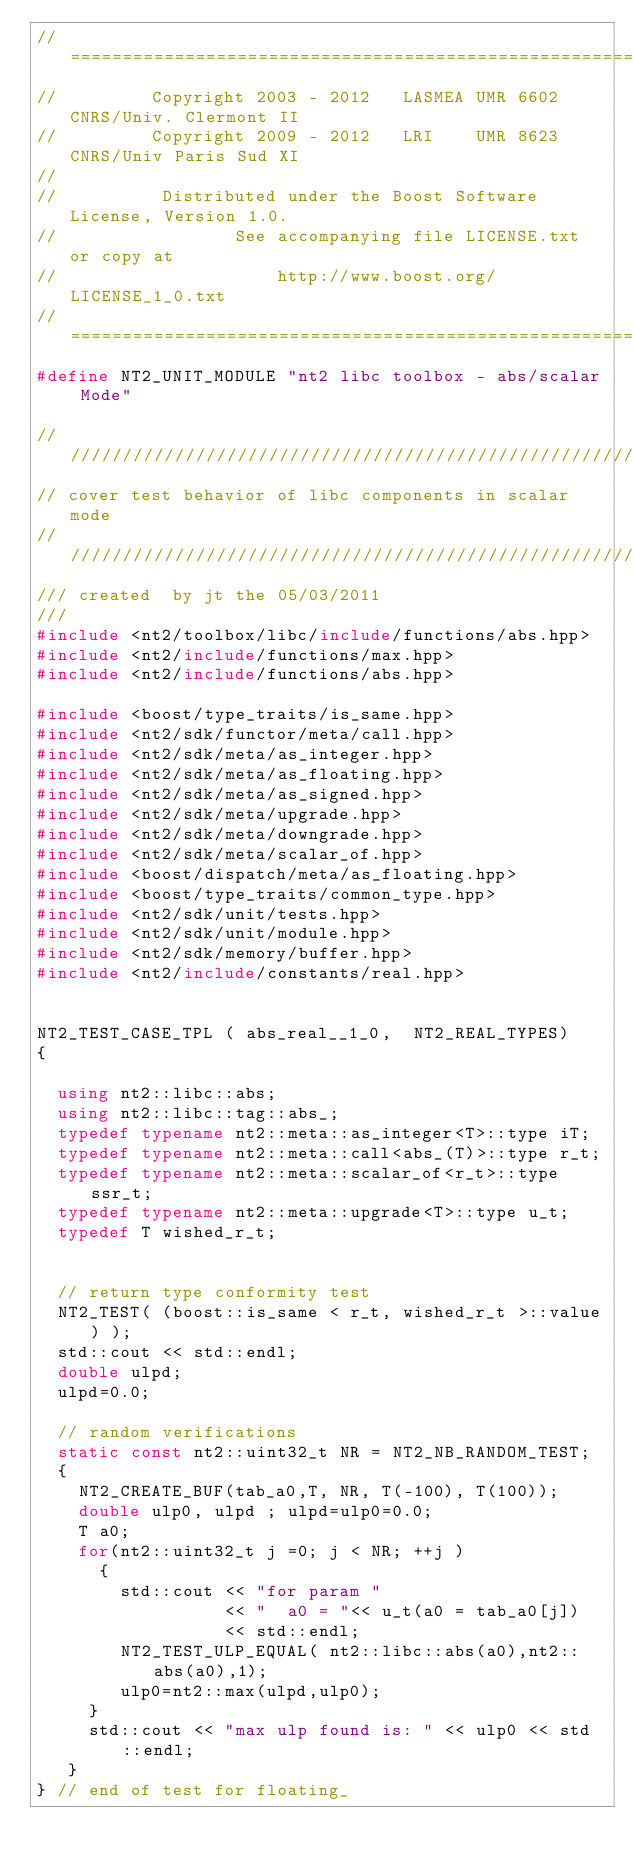<code> <loc_0><loc_0><loc_500><loc_500><_C++_>//==============================================================================
//         Copyright 2003 - 2012   LASMEA UMR 6602 CNRS/Univ. Clermont II
//         Copyright 2009 - 2012   LRI    UMR 8623 CNRS/Univ Paris Sud XI
//
//          Distributed under the Boost Software License, Version 1.0.
//                 See accompanying file LICENSE.txt or copy at
//                     http://www.boost.org/LICENSE_1_0.txt
//==============================================================================
#define NT2_UNIT_MODULE "nt2 libc toolbox - abs/scalar Mode"

//////////////////////////////////////////////////////////////////////////////
// cover test behavior of libc components in scalar mode
//////////////////////////////////////////////////////////////////////////////
/// created  by jt the 05/03/2011
///
#include <nt2/toolbox/libc/include/functions/abs.hpp>
#include <nt2/include/functions/max.hpp>
#include <nt2/include/functions/abs.hpp>

#include <boost/type_traits/is_same.hpp>
#include <nt2/sdk/functor/meta/call.hpp>
#include <nt2/sdk/meta/as_integer.hpp>
#include <nt2/sdk/meta/as_floating.hpp>
#include <nt2/sdk/meta/as_signed.hpp>
#include <nt2/sdk/meta/upgrade.hpp>
#include <nt2/sdk/meta/downgrade.hpp>
#include <nt2/sdk/meta/scalar_of.hpp>
#include <boost/dispatch/meta/as_floating.hpp>
#include <boost/type_traits/common_type.hpp>
#include <nt2/sdk/unit/tests.hpp>
#include <nt2/sdk/unit/module.hpp>
#include <nt2/sdk/memory/buffer.hpp>
#include <nt2/include/constants/real.hpp>


NT2_TEST_CASE_TPL ( abs_real__1_0,  NT2_REAL_TYPES)
{

  using nt2::libc::abs;
  using nt2::libc::tag::abs_;
  typedef typename nt2::meta::as_integer<T>::type iT;
  typedef typename nt2::meta::call<abs_(T)>::type r_t;
  typedef typename nt2::meta::scalar_of<r_t>::type ssr_t;
  typedef typename nt2::meta::upgrade<T>::type u_t;
  typedef T wished_r_t;


  // return type conformity test
  NT2_TEST( (boost::is_same < r_t, wished_r_t >::value) );
  std::cout << std::endl;
  double ulpd;
  ulpd=0.0;

  // random verifications
  static const nt2::uint32_t NR = NT2_NB_RANDOM_TEST;
  {
    NT2_CREATE_BUF(tab_a0,T, NR, T(-100), T(100));
    double ulp0, ulpd ; ulpd=ulp0=0.0;
    T a0;
    for(nt2::uint32_t j =0; j < NR; ++j )
      {
        std::cout << "for param "
                  << "  a0 = "<< u_t(a0 = tab_a0[j])
                  << std::endl;
        NT2_TEST_ULP_EQUAL( nt2::libc::abs(a0),nt2::abs(a0),1);
        ulp0=nt2::max(ulpd,ulp0);
     }
     std::cout << "max ulp found is: " << ulp0 << std::endl;
   }
} // end of test for floating_
</code> 